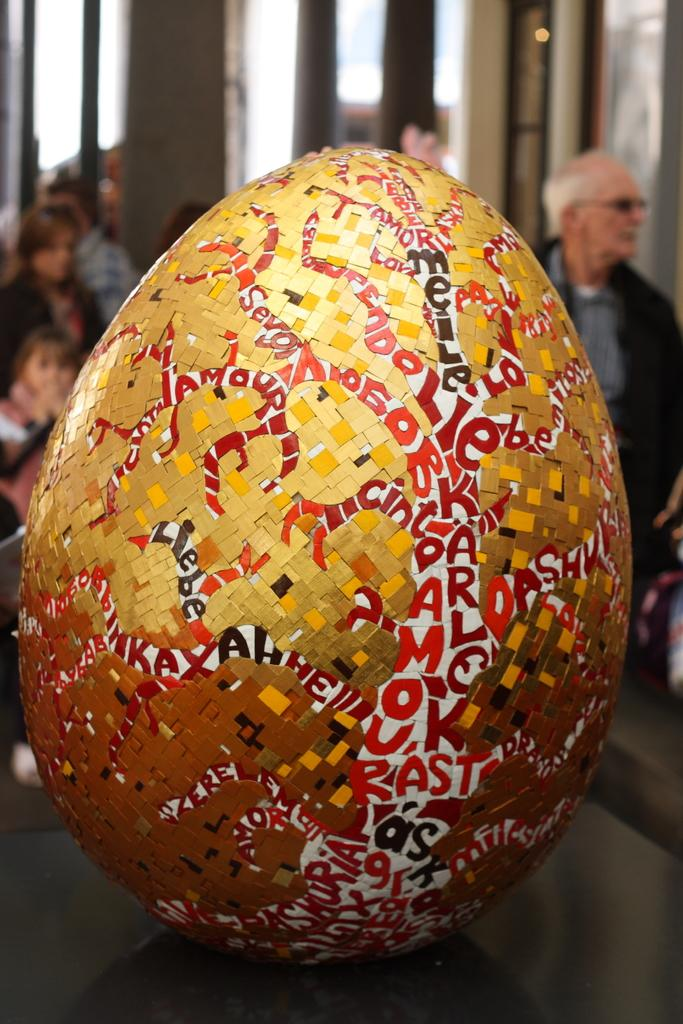What is the shape of the object in the image? The object in the image is oval-shaped. What can be seen on the surface of the object? The object has text on it. Who or what is located behind the object? There are people behind the object. How would you describe the background of the image? The background of the image is blurred. What type of waste is being disposed of in the image? There is no waste present in the image; it features an oval-shaped object with text on it, people behind it, and a blurred background. 